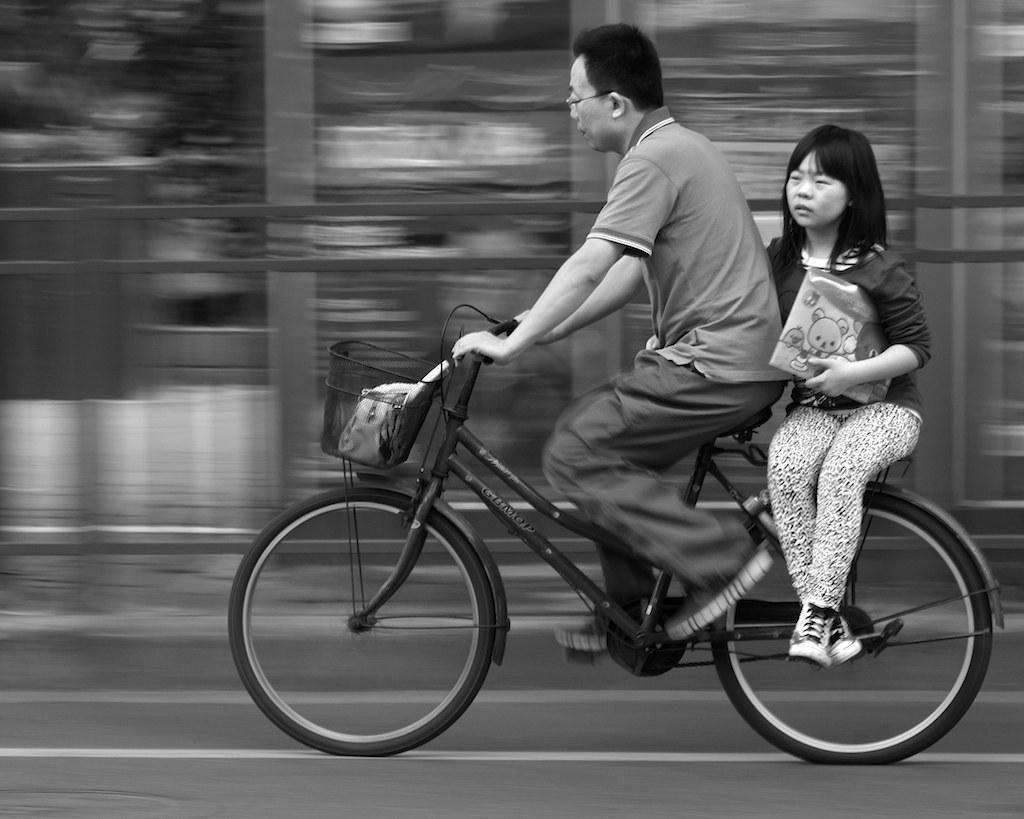What is the man in the image doing? The man is riding a bicycle in the image. Who is with the man on the bicycle? There is a kid sitting behind the man on the bicycle. What is the kid holding in her hand? The kid is holding an object in her hand. What type of pest can be seen crawling on the man's leg in the image? There is no pest visible on the man's leg in the image. What kind of metal is used to construct the bicycle in the image? The type of metal used to construct the bicycle is not mentioned in the image. 